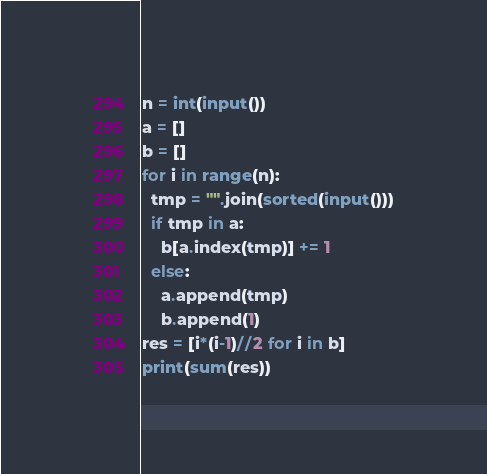Convert code to text. <code><loc_0><loc_0><loc_500><loc_500><_Python_>n = int(input())
a = []
b = []
for i in range(n):
  tmp = "".join(sorted(input()))
  if tmp in a:
    b[a.index(tmp)] += 1
  else:
    a.append(tmp)
    b.append(1)
res = [i*(i-1)//2 for i in b]
print(sum(res))
</code> 